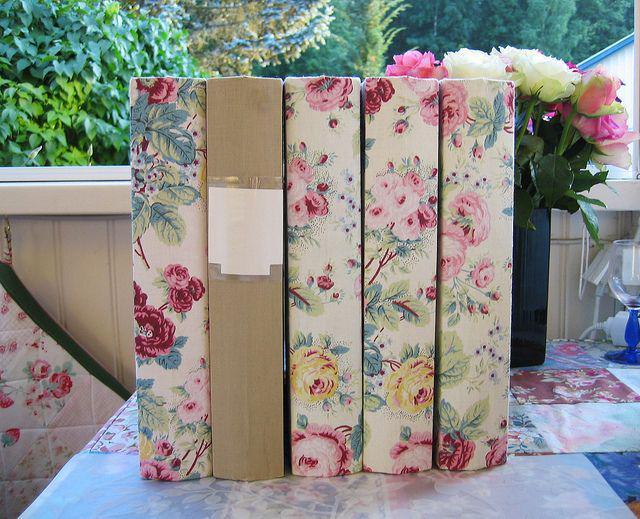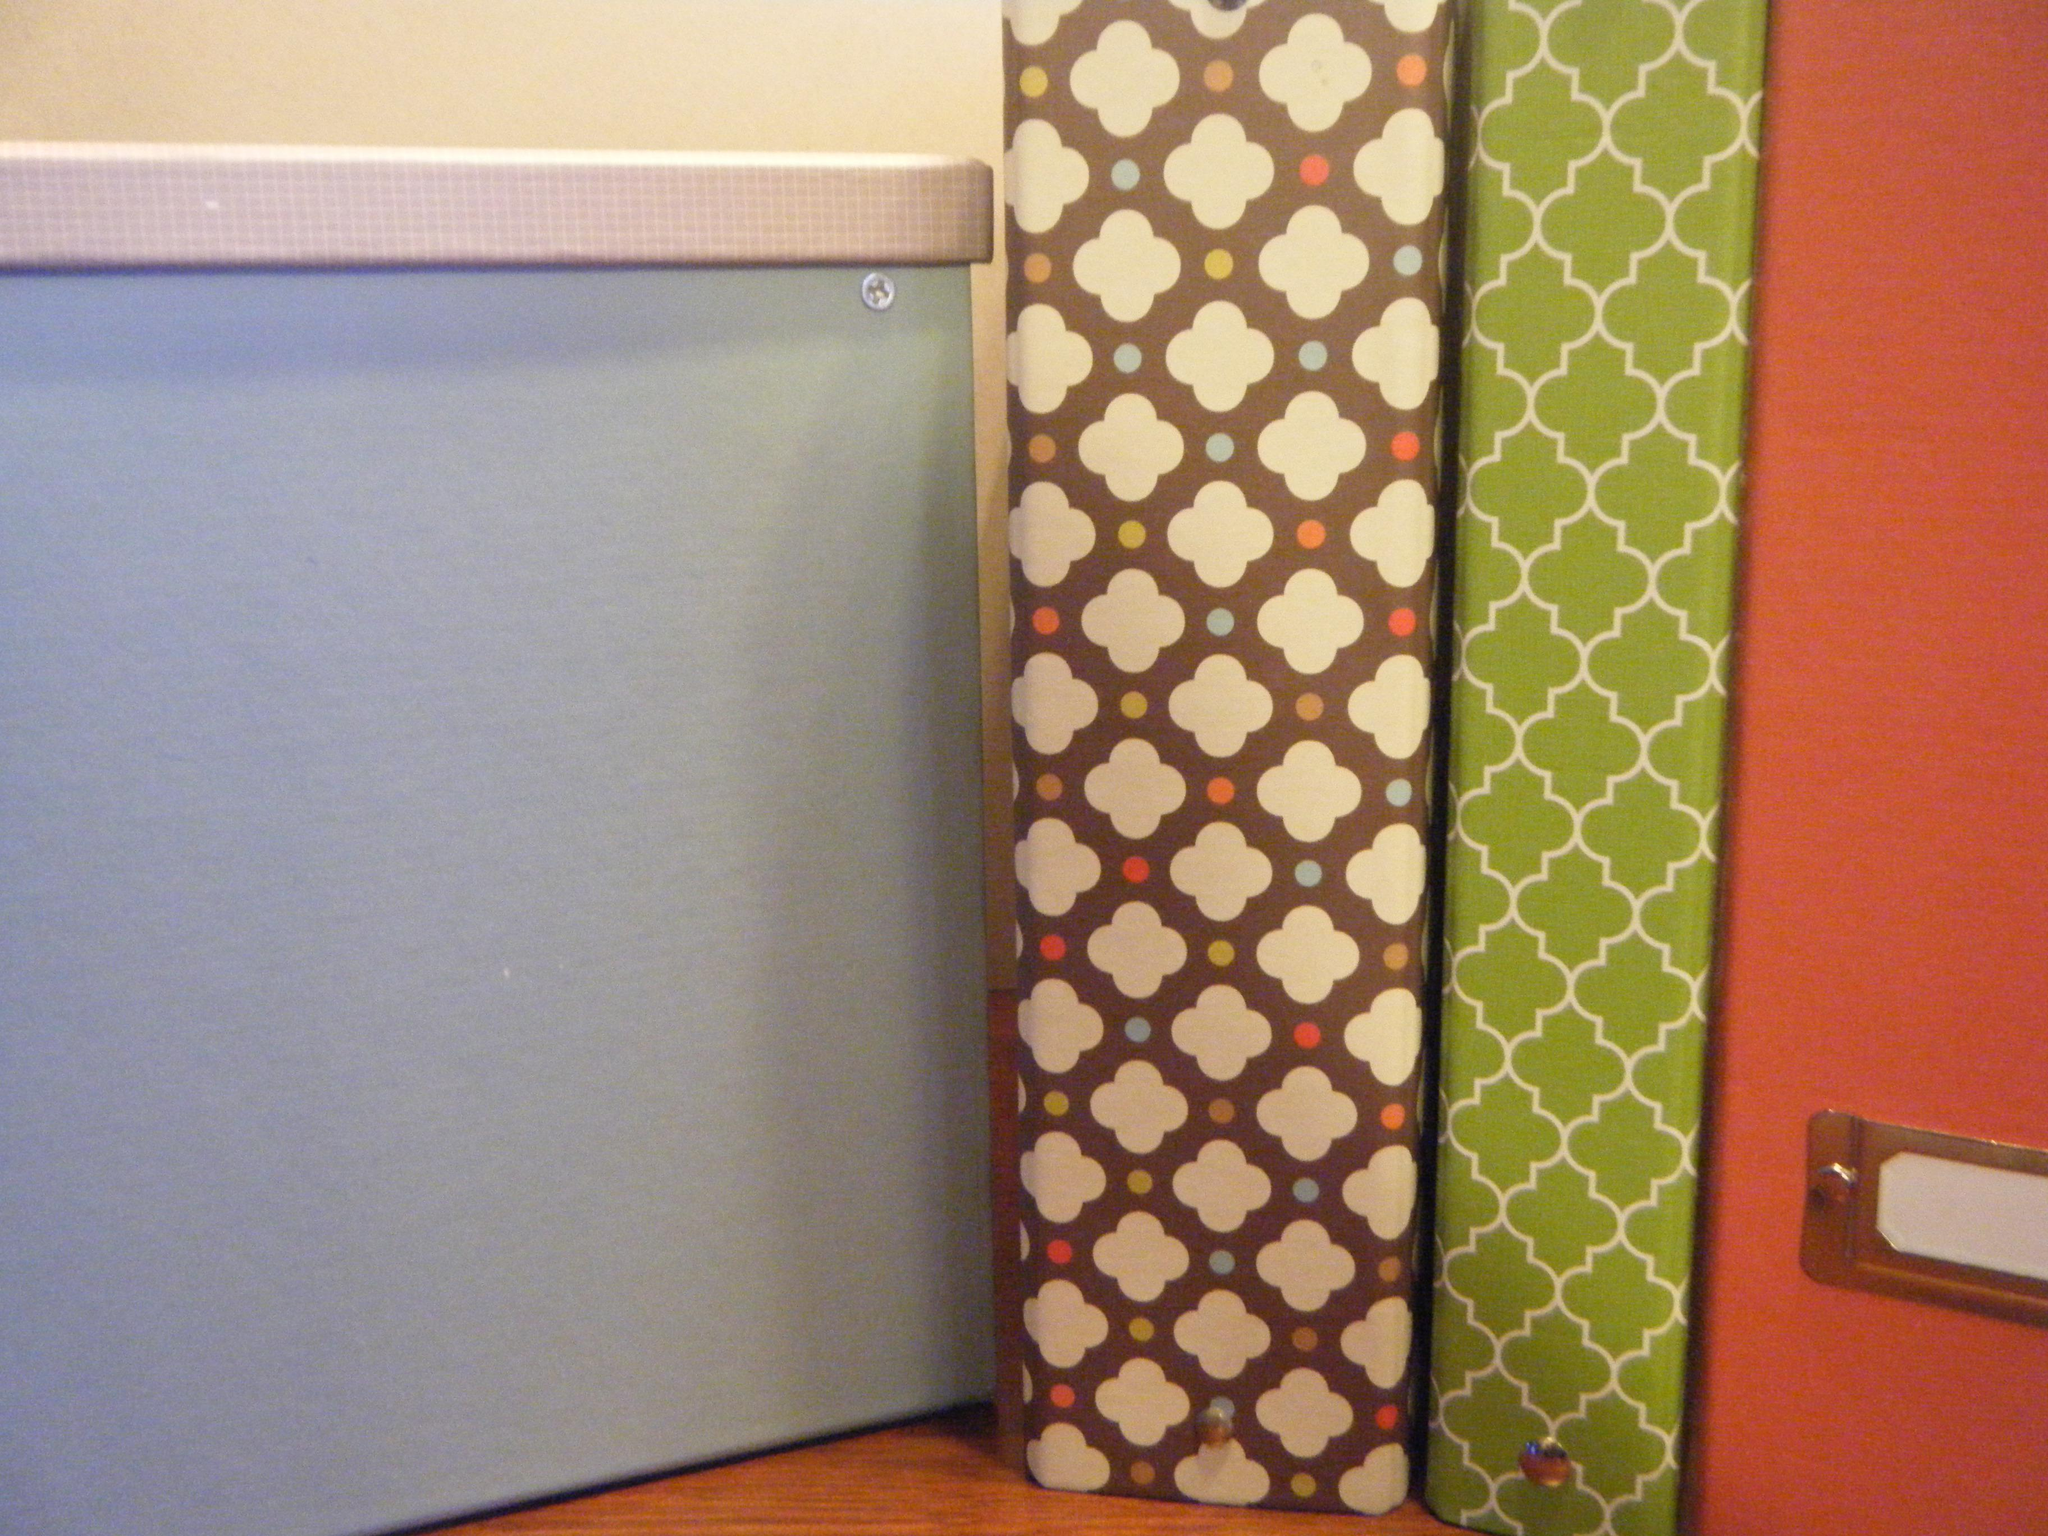The first image is the image on the left, the second image is the image on the right. Considering the images on both sides, is "There is a single floral binder in the image on the right." valid? Answer yes or no. No. The first image is the image on the left, the second image is the image on the right. For the images displayed, is the sentence "One image shows exactly five binders displayed side-by-side." factually correct? Answer yes or no. Yes. 